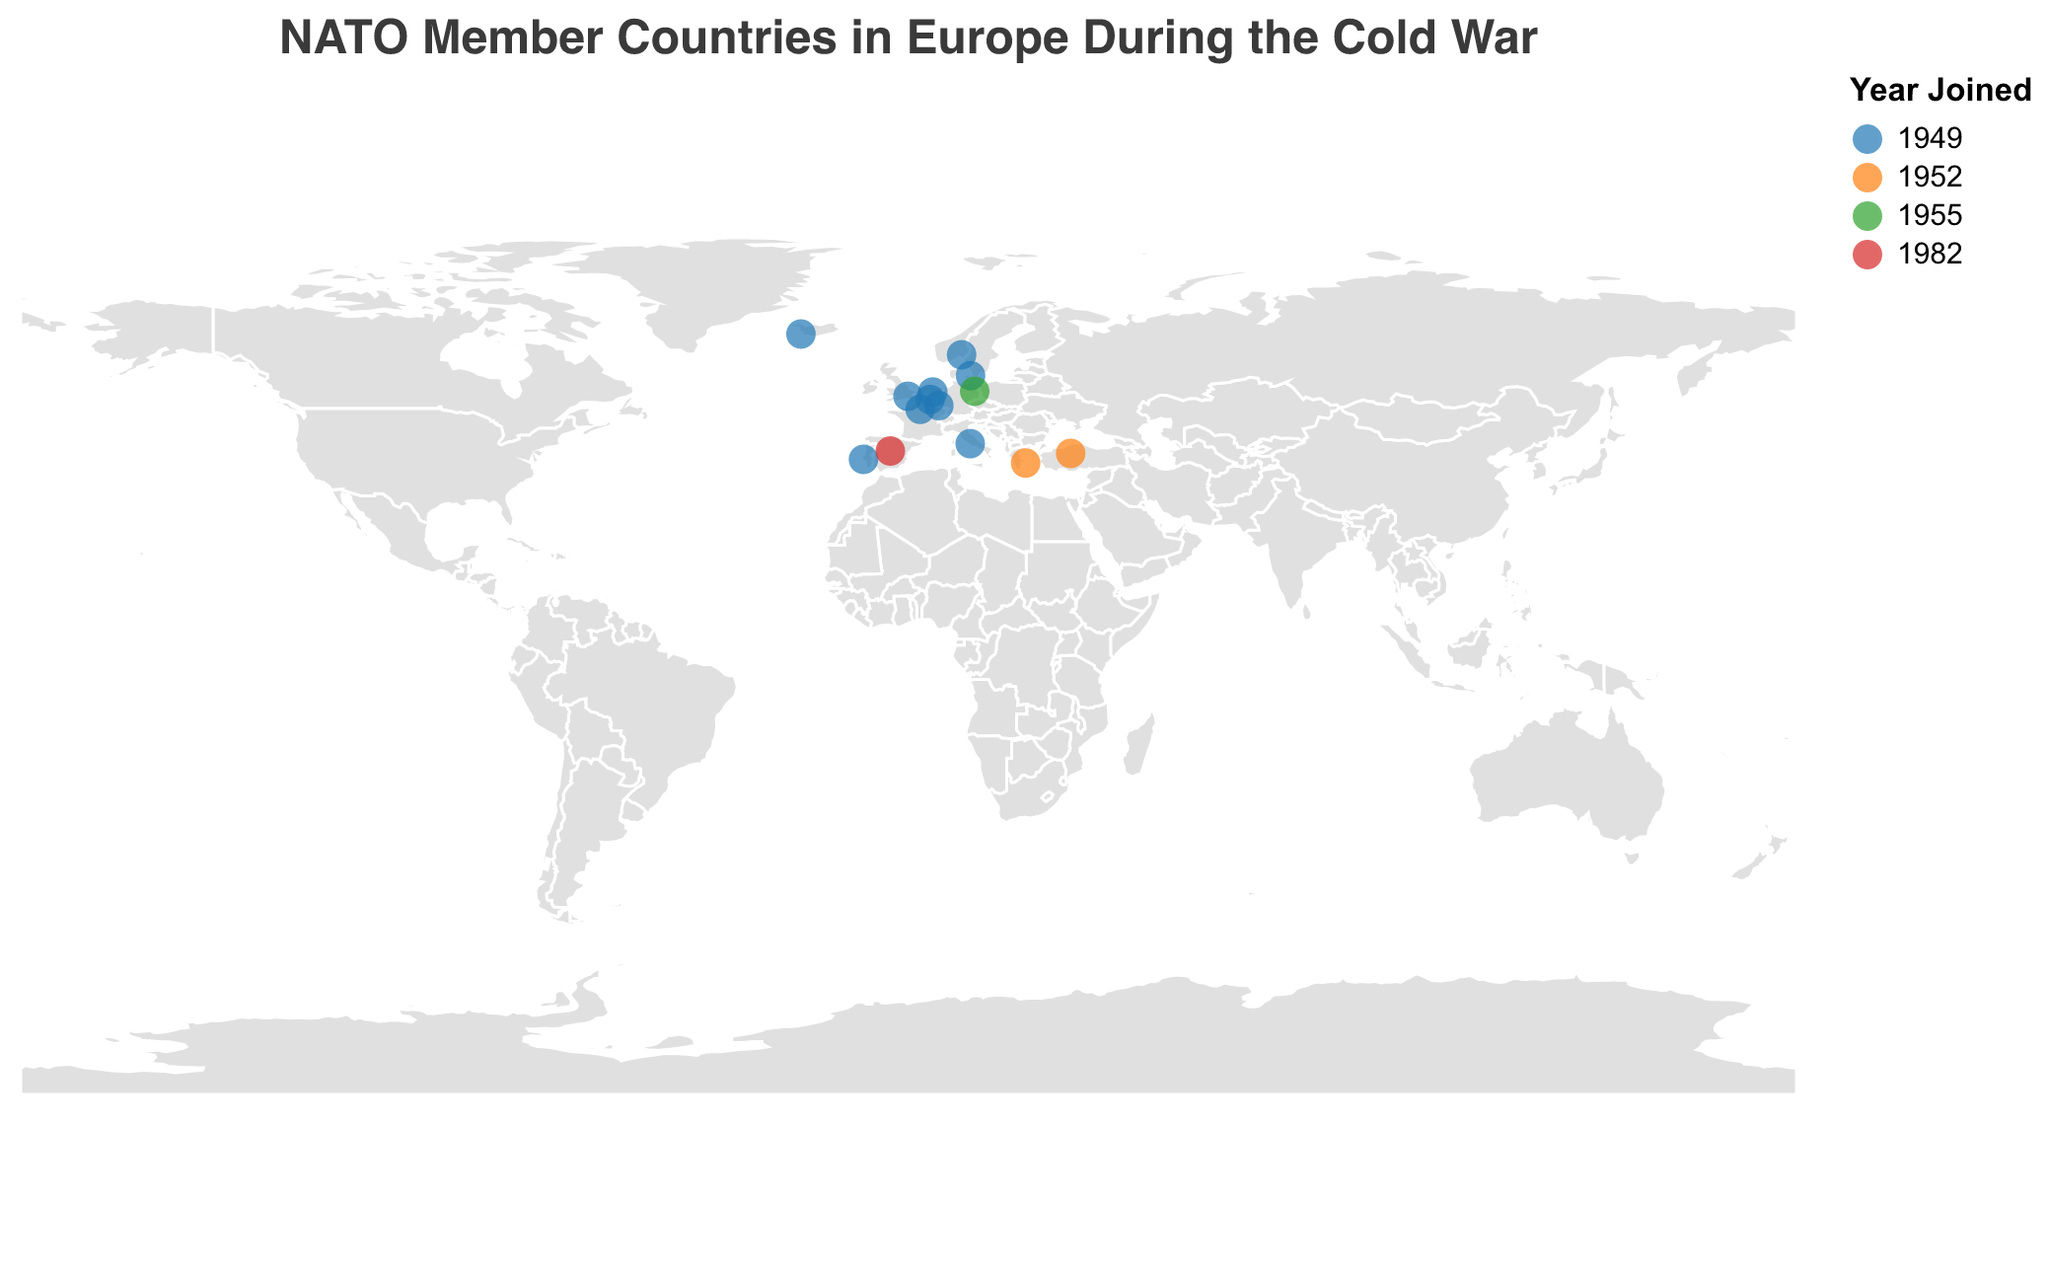What is the title of the figure? The title of the figure is usually located at the top and displayed prominently. In this case, it is clearly indicated as "NATO Member Countries in Europe During the Cold War."
Answer: NATO Member Countries in Europe During the Cold War Which country was the first to join NATO and in which year? By looking at the tooltip associated with the circles, several countries joined NATO in 1949. However, the first listed country alphabetically that joined in 1949 is Belgium.
Answer: Belgium, 1949 How many countries joined NATO in 1949? To find this, locate all circles colored in the shade that represents 1949. Count the number of these circles. The identified countries are Belgium, Denmark, France, Iceland, Italy, Luxembourg, Netherlands, Norway, Portugal, and the United Kingdom. This amounts to a total of 10 countries.
Answer: 10 countries Which countries are represented by the color that indicates their joining year as 1982? Check the color legend corresponding to the year 1982, which is a specific red shade. Only Spain’s circle matches this color.
Answer: Spain What is the geographical spread of countries that joined NATO in 1952? The countries that joined NATO in 1952, represented by the corresponding color, are Greece and Turkey. The geographical spread can be identified by locating these countries on the map. Greece is located in Southern Europe, whereas Turkey is in both Southeastern Europe and Western Asia.
Answer: Southern Europe and Southeastern Europe/Western Asia Which NATO member country during the Cold War is located farthest north? Identify the northernmost circle by referring to the latitude values. Iceland, with a latitude of 64.1265, is the most northern country.
Answer: Iceland Compare the number of countries that joined NATO in 1949 with those that joined in the later years. Did more countries join in 1949 or in the subsequent years combined? Count and compare the number of circles of the respective colors. In 1949, 10 countries joined. In subsequent years: 1952 (2 countries), 1955 (1 country), and 1982 (1 country), adding up to 4 countries. Thus, more countries joined in 1949.
Answer: More in 1949 What is the median year of NATO accession for the countries shown on the map? List the years the countries joined and find the median. The years are 1949, 1949, 1949, 1949, 1949, 1949, 1949, 1949, 1949, 1949, 1952, 1952, 1955, 1982. Arranging these in order, the seventh and eighth years are both 1949, so the median year is 1949.
Answer: 1949 Which country joined NATO between Greece and Spain? Based on the tooltip information and years of accession, West Germany joined in 1955, which falls between Greece (1952) and Spain (1982).
Answer: West Germany 